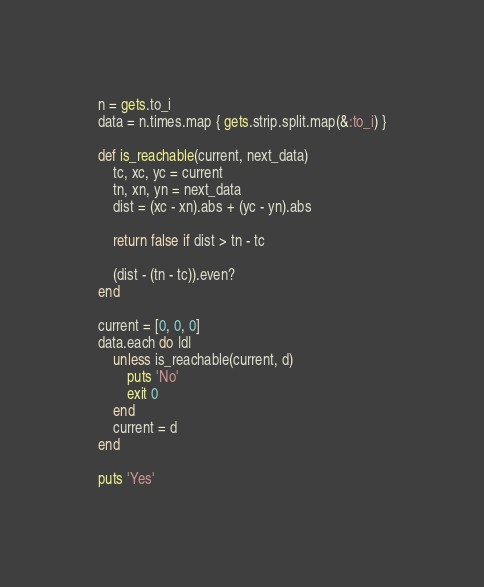<code> <loc_0><loc_0><loc_500><loc_500><_Ruby_>n = gets.to_i
data = n.times.map { gets.strip.split.map(&:to_i) }

def is_reachable(current, next_data)
    tc, xc, yc = current
    tn, xn, yn = next_data
    dist = (xc - xn).abs + (yc - yn).abs
    
    return false if dist > tn - tc

    (dist - (tn - tc)).even?
end

current = [0, 0, 0]
data.each do |d|
    unless is_reachable(current, d)
        puts 'No'
        exit 0
    end
    current = d
end

puts 'Yes'
</code> 